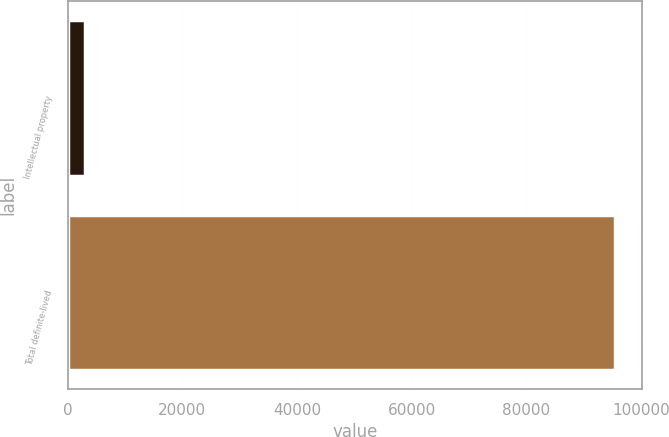<chart> <loc_0><loc_0><loc_500><loc_500><bar_chart><fcel>Intellectual property<fcel>Total definite-lived<nl><fcel>2988<fcel>95435<nl></chart> 